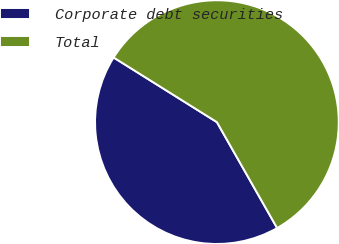Convert chart to OTSL. <chart><loc_0><loc_0><loc_500><loc_500><pie_chart><fcel>Corporate debt securities<fcel>Total<nl><fcel>42.13%<fcel>57.87%<nl></chart> 